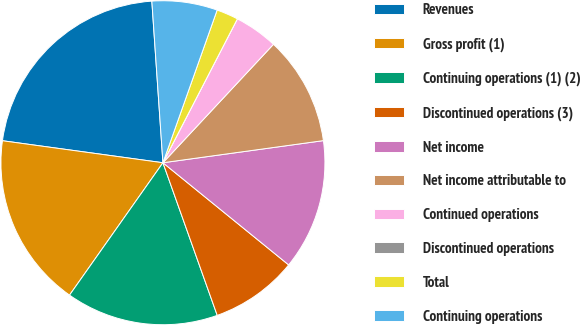<chart> <loc_0><loc_0><loc_500><loc_500><pie_chart><fcel>Revenues<fcel>Gross profit (1)<fcel>Continuing operations (1) (2)<fcel>Discontinued operations (3)<fcel>Net income<fcel>Net income attributable to<fcel>Continued operations<fcel>Discontinued operations<fcel>Total<fcel>Continuing operations<nl><fcel>21.74%<fcel>17.39%<fcel>15.22%<fcel>8.7%<fcel>13.04%<fcel>10.87%<fcel>4.35%<fcel>0.0%<fcel>2.17%<fcel>6.52%<nl></chart> 